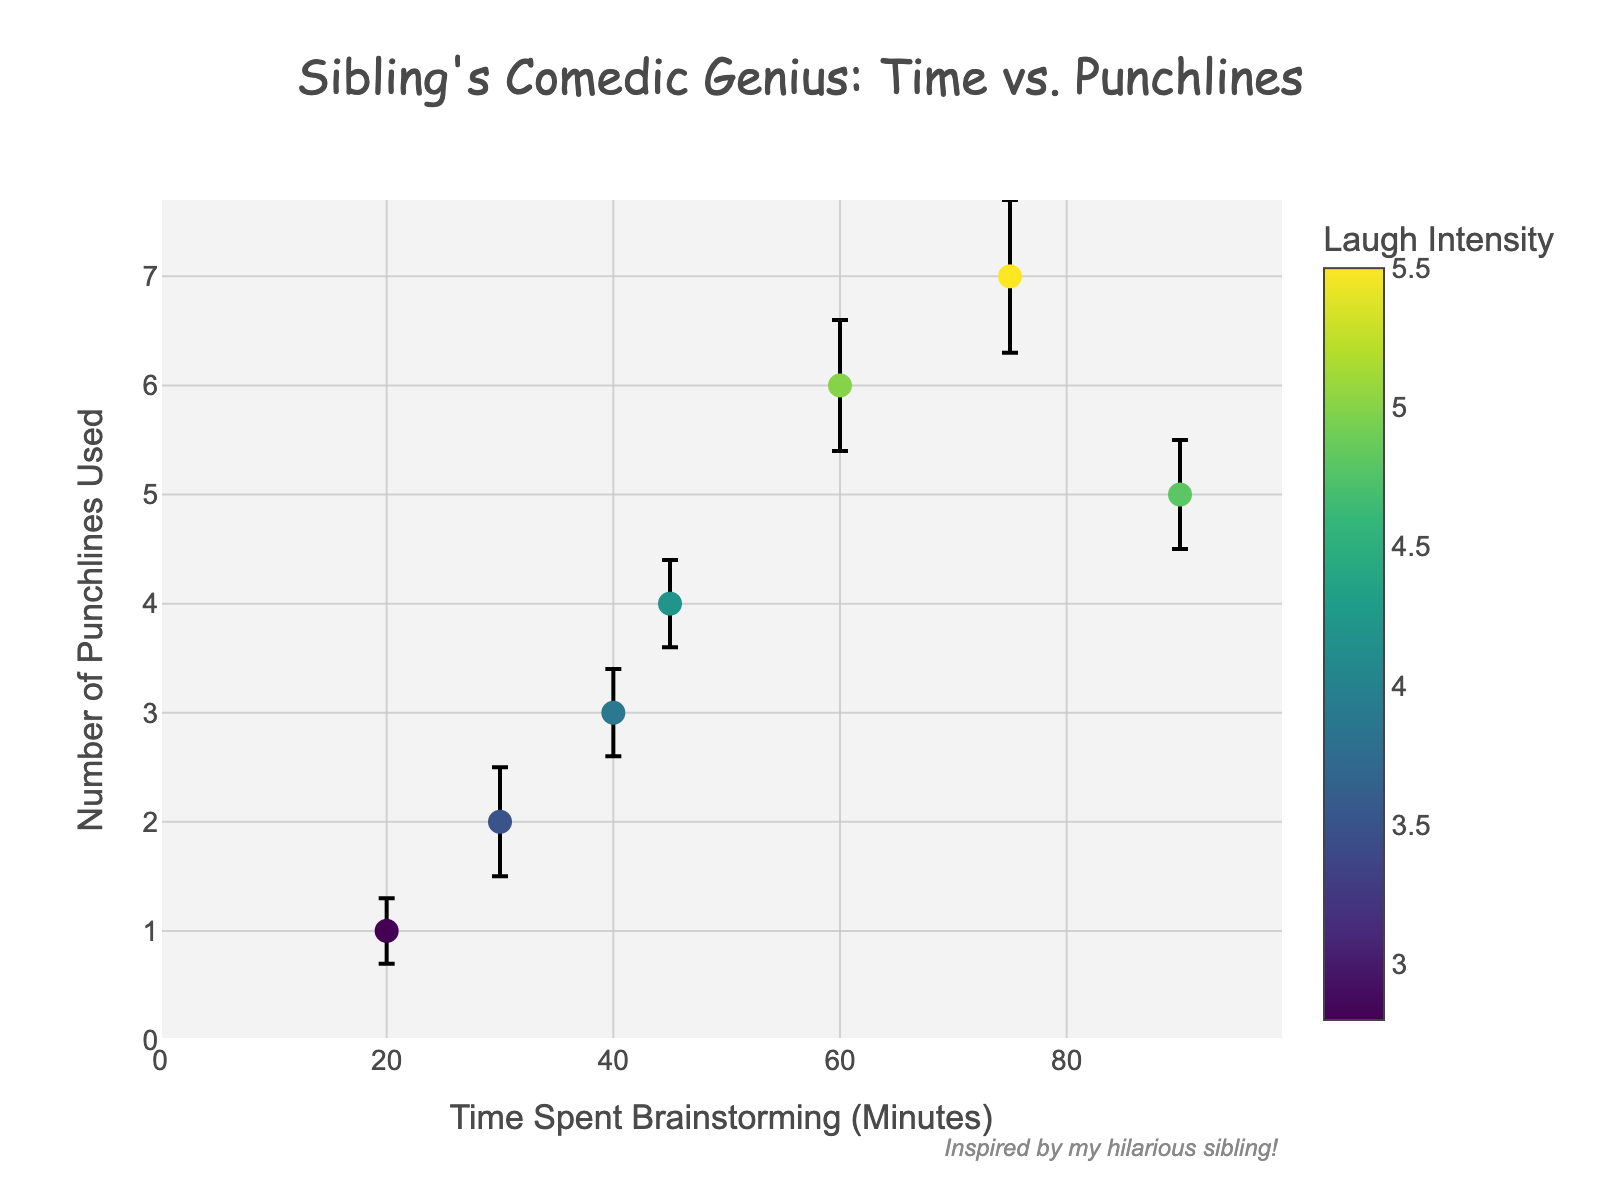What is the title of the scatter plot? The title can be found at the top of the figure. It reads: "Sibling's Comedic Genius: Time vs. Punchlines"
Answer: Sibling's Comedic Genius: Time vs. Punchlines How many data points are plotted in the scatter plot? The data points are represented by markers, and by counting them we find there are 7 markers on the plot.
Answer: 7 What is the y-axis title? The y-axis title is found along the vertical axis on the left side of the figure. It reads "Number of Punchlines Used".
Answer: Number of Punchlines Used Which data point has the highest number of punchlines used, and what is the corresponding time spent brainstorming? By examining the y-axis value each marker represents, the data point with the highest number of punchlines used is 7. The corresponding time spent brainstorming for this point is 75 minutes.
Answer: 75 minutes For the data point where the time spent brainstorming is 60 minutes, what's the associated laugh intensity and its error bar? Find the marker at 60 minutes on the x-axis, and check the hover text or color bar. The associated laugh intensity is 5.0 with an error bar of ±0.6.
Answer: 5.0 ±0.6 What is the color scale used for laugh intensity? The color scale is shown on the color bar to the right of the plot, and it is labeled ‘Viridis’.
Answer: Viridis Which data point has the smallest laugh intensity mean, and what is that mean value? By referring to the color intensity and the hover text, the data point with the smallest laugh intensity mean is at 20 minutes, where the laugh intensity mean is 2.8.
Answer: 2.8 Between time points 40 minutes and 75 minutes, which has a higher number of punchlines used, and by how much? Comparing the y-values at these x-values, 75 minutes has 7 punchlines, while 40 minutes has 3 punchlines. The difference is 4 punchlines.
Answer: 4 punchlines Which spends more time brainstorming: the data point with a laugh intensity of 4.2 or the data point with a laugh intensity of 4.8? Find the markers with these laugh intensity values using the hover text or color. The laugh intensity of 4.2 corresponds to 45 minutes, and 4.8 corresponds to 90 minutes. So, 90 minutes is more.
Answer: 90 minutes What is the average number of punchlines for brainstorming times above 50 minutes? First, identify the data points where the time spent brainstorming is above 50 minutes: 60, 75, and 90 minutes with punchlines 6, 7, and 5 respectively. Sum them up (6+7+5) = 18 and divide by 3.
Answer: 6 